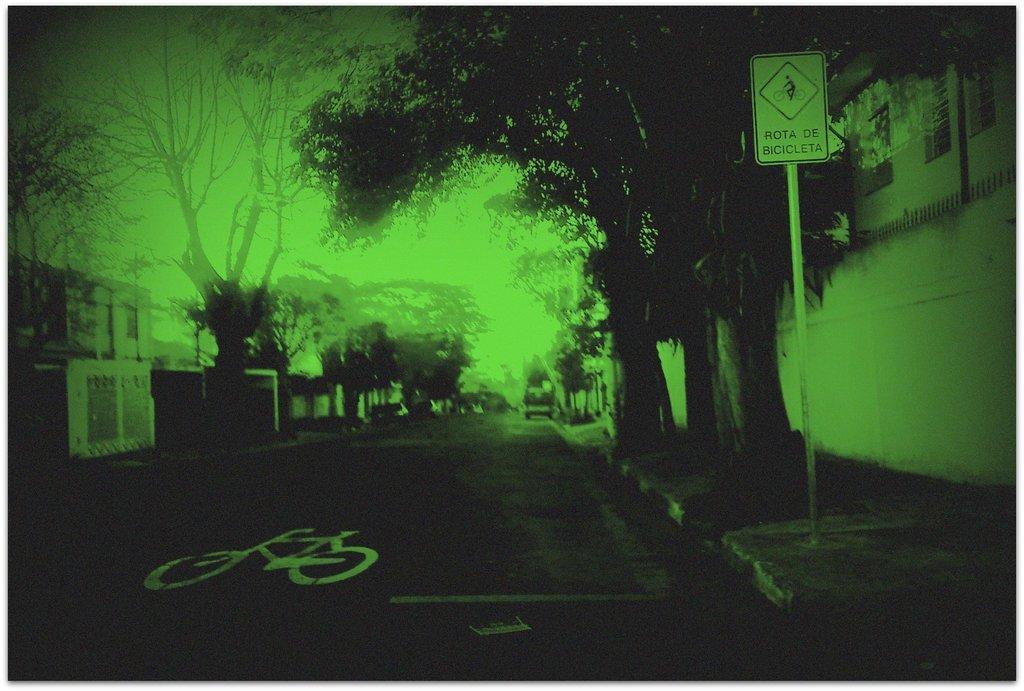Can you describe this image briefly? In this image we can see a road. On the sides of the road there are trees. Also there is a sign board with a pole. And there is a wall. And the image is looking green. 